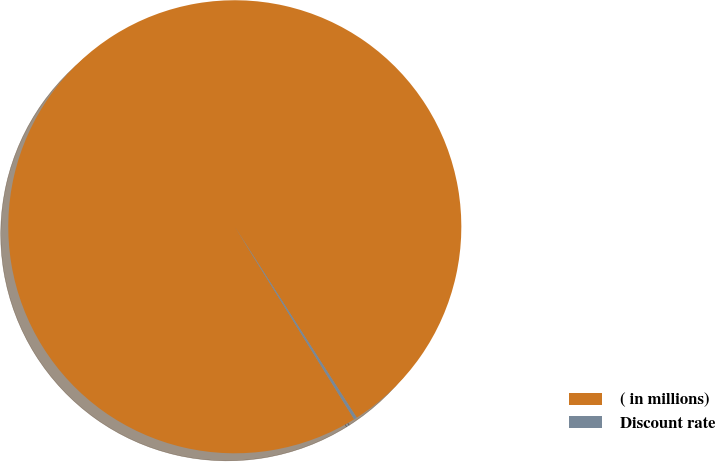Convert chart. <chart><loc_0><loc_0><loc_500><loc_500><pie_chart><fcel>( in millions)<fcel>Discount rate<nl><fcel>99.79%<fcel>0.21%<nl></chart> 